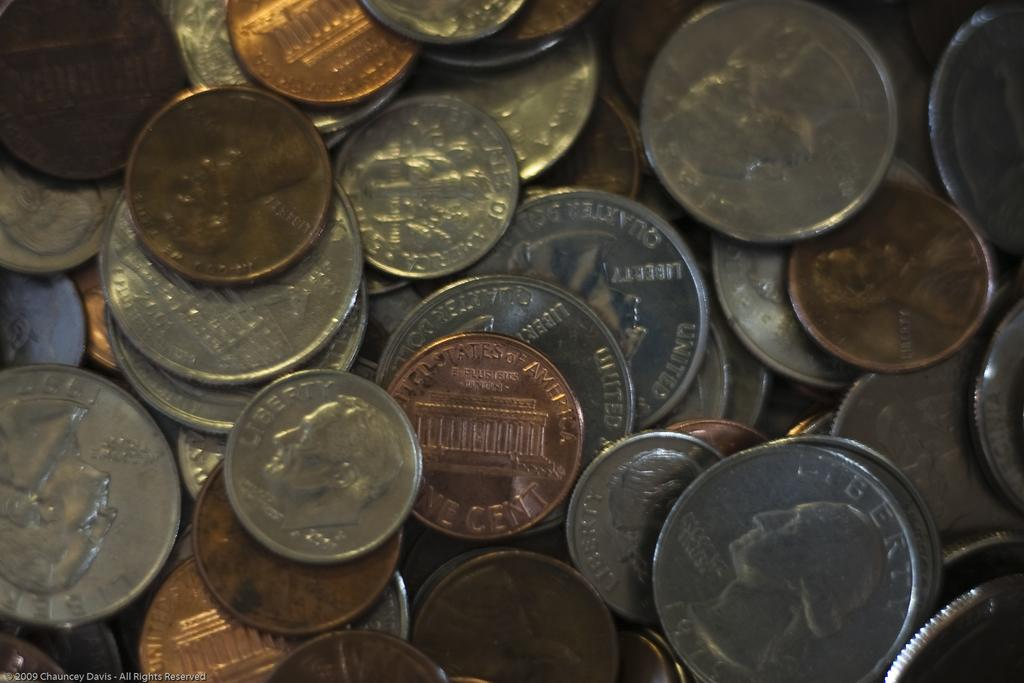<image>
Give a short and clear explanation of the subsequent image. A big pile of American coins are on top of each other including a quarter from 1957. 